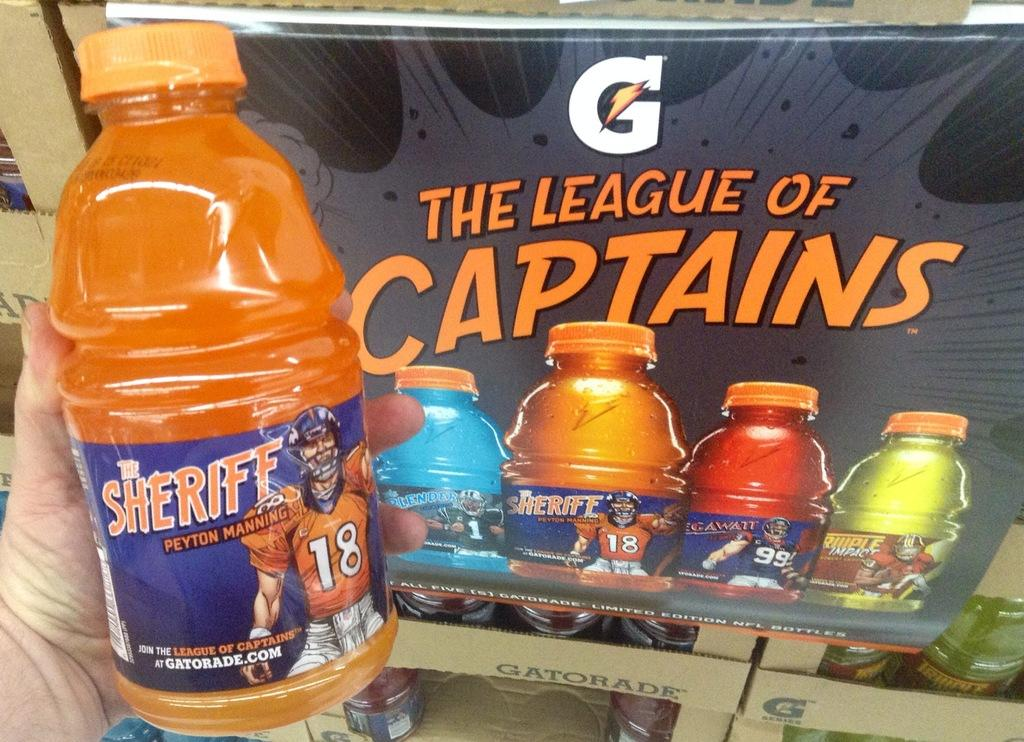What is the person in the image holding? The person is holding a bottle in the image. What can be seen on the right side of the image? There is a board on the right side of the image. What is depicted on the board? There are painted bottles on the board. How does the beggar in the image ask for money? There is no beggar present in the image. What type of bead is used to create the painted bottles on the board? The provided facts do not mention any beads being used to create the painted bottles on the board. 